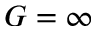<formula> <loc_0><loc_0><loc_500><loc_500>G = \infty</formula> 